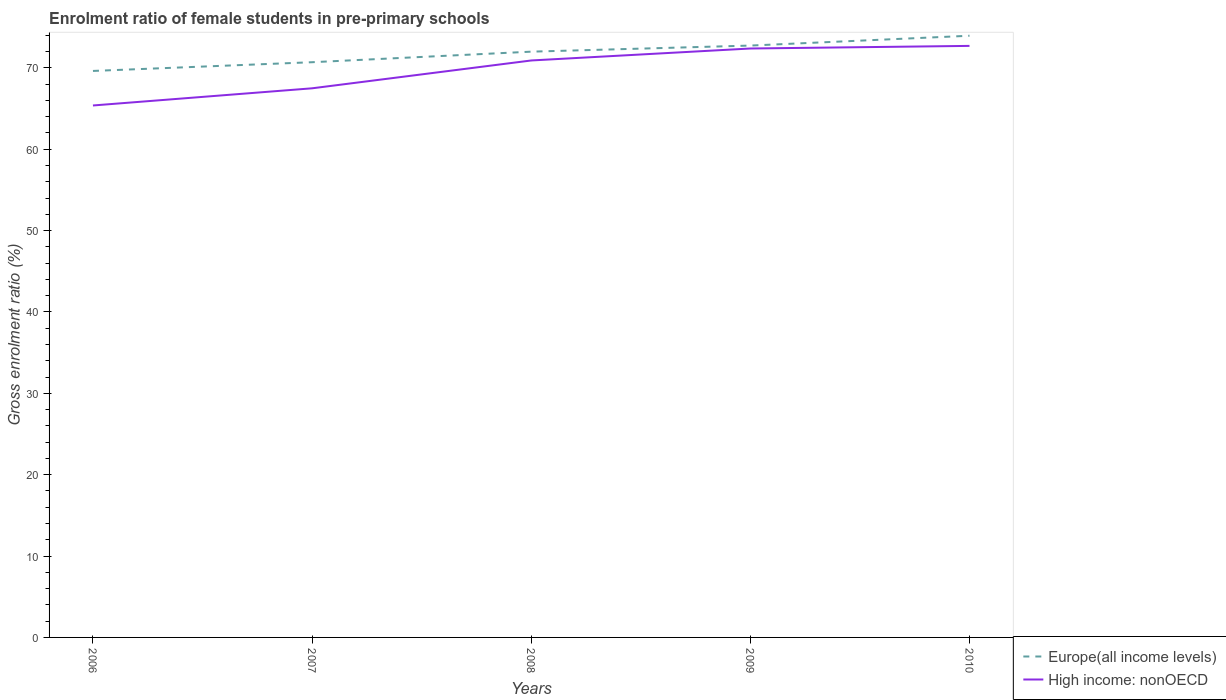Does the line corresponding to Europe(all income levels) intersect with the line corresponding to High income: nonOECD?
Your answer should be very brief. No. Is the number of lines equal to the number of legend labels?
Offer a terse response. Yes. Across all years, what is the maximum enrolment ratio of female students in pre-primary schools in High income: nonOECD?
Give a very brief answer. 65.37. In which year was the enrolment ratio of female students in pre-primary schools in High income: nonOECD maximum?
Make the answer very short. 2006. What is the total enrolment ratio of female students in pre-primary schools in Europe(all income levels) in the graph?
Offer a terse response. -2.05. What is the difference between the highest and the second highest enrolment ratio of female students in pre-primary schools in High income: nonOECD?
Offer a terse response. 7.32. How many lines are there?
Ensure brevity in your answer.  2. How many years are there in the graph?
Give a very brief answer. 5. Are the values on the major ticks of Y-axis written in scientific E-notation?
Provide a succinct answer. No. Does the graph contain any zero values?
Ensure brevity in your answer.  No. Does the graph contain grids?
Ensure brevity in your answer.  No. Where does the legend appear in the graph?
Offer a very short reply. Bottom right. What is the title of the graph?
Offer a very short reply. Enrolment ratio of female students in pre-primary schools. Does "Jordan" appear as one of the legend labels in the graph?
Your response must be concise. No. What is the Gross enrolment ratio (%) of Europe(all income levels) in 2006?
Offer a terse response. 69.62. What is the Gross enrolment ratio (%) of High income: nonOECD in 2006?
Offer a terse response. 65.37. What is the Gross enrolment ratio (%) of Europe(all income levels) in 2007?
Provide a succinct answer. 70.69. What is the Gross enrolment ratio (%) in High income: nonOECD in 2007?
Give a very brief answer. 67.48. What is the Gross enrolment ratio (%) of Europe(all income levels) in 2008?
Your answer should be compact. 71.99. What is the Gross enrolment ratio (%) in High income: nonOECD in 2008?
Offer a terse response. 70.9. What is the Gross enrolment ratio (%) in Europe(all income levels) in 2009?
Make the answer very short. 72.73. What is the Gross enrolment ratio (%) of High income: nonOECD in 2009?
Give a very brief answer. 72.37. What is the Gross enrolment ratio (%) in Europe(all income levels) in 2010?
Provide a short and direct response. 73.94. What is the Gross enrolment ratio (%) of High income: nonOECD in 2010?
Keep it short and to the point. 72.69. Across all years, what is the maximum Gross enrolment ratio (%) of Europe(all income levels)?
Offer a very short reply. 73.94. Across all years, what is the maximum Gross enrolment ratio (%) in High income: nonOECD?
Your answer should be very brief. 72.69. Across all years, what is the minimum Gross enrolment ratio (%) of Europe(all income levels)?
Keep it short and to the point. 69.62. Across all years, what is the minimum Gross enrolment ratio (%) in High income: nonOECD?
Offer a terse response. 65.37. What is the total Gross enrolment ratio (%) of Europe(all income levels) in the graph?
Give a very brief answer. 358.97. What is the total Gross enrolment ratio (%) in High income: nonOECD in the graph?
Offer a very short reply. 348.82. What is the difference between the Gross enrolment ratio (%) in Europe(all income levels) in 2006 and that in 2007?
Provide a succinct answer. -1.07. What is the difference between the Gross enrolment ratio (%) in High income: nonOECD in 2006 and that in 2007?
Offer a very short reply. -2.11. What is the difference between the Gross enrolment ratio (%) in Europe(all income levels) in 2006 and that in 2008?
Provide a succinct answer. -2.37. What is the difference between the Gross enrolment ratio (%) in High income: nonOECD in 2006 and that in 2008?
Your answer should be very brief. -5.53. What is the difference between the Gross enrolment ratio (%) in Europe(all income levels) in 2006 and that in 2009?
Your answer should be compact. -3.12. What is the difference between the Gross enrolment ratio (%) in High income: nonOECD in 2006 and that in 2009?
Make the answer very short. -7. What is the difference between the Gross enrolment ratio (%) of Europe(all income levels) in 2006 and that in 2010?
Offer a terse response. -4.33. What is the difference between the Gross enrolment ratio (%) in High income: nonOECD in 2006 and that in 2010?
Your response must be concise. -7.32. What is the difference between the Gross enrolment ratio (%) of Europe(all income levels) in 2007 and that in 2008?
Your answer should be very brief. -1.3. What is the difference between the Gross enrolment ratio (%) in High income: nonOECD in 2007 and that in 2008?
Provide a short and direct response. -3.42. What is the difference between the Gross enrolment ratio (%) in Europe(all income levels) in 2007 and that in 2009?
Offer a very short reply. -2.05. What is the difference between the Gross enrolment ratio (%) of High income: nonOECD in 2007 and that in 2009?
Provide a short and direct response. -4.89. What is the difference between the Gross enrolment ratio (%) of Europe(all income levels) in 2007 and that in 2010?
Provide a short and direct response. -3.25. What is the difference between the Gross enrolment ratio (%) in High income: nonOECD in 2007 and that in 2010?
Your answer should be very brief. -5.21. What is the difference between the Gross enrolment ratio (%) of Europe(all income levels) in 2008 and that in 2009?
Provide a short and direct response. -0.75. What is the difference between the Gross enrolment ratio (%) of High income: nonOECD in 2008 and that in 2009?
Provide a short and direct response. -1.47. What is the difference between the Gross enrolment ratio (%) of Europe(all income levels) in 2008 and that in 2010?
Offer a very short reply. -1.96. What is the difference between the Gross enrolment ratio (%) of High income: nonOECD in 2008 and that in 2010?
Make the answer very short. -1.79. What is the difference between the Gross enrolment ratio (%) of Europe(all income levels) in 2009 and that in 2010?
Provide a succinct answer. -1.21. What is the difference between the Gross enrolment ratio (%) of High income: nonOECD in 2009 and that in 2010?
Offer a very short reply. -0.32. What is the difference between the Gross enrolment ratio (%) of Europe(all income levels) in 2006 and the Gross enrolment ratio (%) of High income: nonOECD in 2007?
Provide a succinct answer. 2.13. What is the difference between the Gross enrolment ratio (%) in Europe(all income levels) in 2006 and the Gross enrolment ratio (%) in High income: nonOECD in 2008?
Give a very brief answer. -1.29. What is the difference between the Gross enrolment ratio (%) in Europe(all income levels) in 2006 and the Gross enrolment ratio (%) in High income: nonOECD in 2009?
Your response must be concise. -2.76. What is the difference between the Gross enrolment ratio (%) in Europe(all income levels) in 2006 and the Gross enrolment ratio (%) in High income: nonOECD in 2010?
Offer a very short reply. -3.08. What is the difference between the Gross enrolment ratio (%) of Europe(all income levels) in 2007 and the Gross enrolment ratio (%) of High income: nonOECD in 2008?
Make the answer very short. -0.21. What is the difference between the Gross enrolment ratio (%) in Europe(all income levels) in 2007 and the Gross enrolment ratio (%) in High income: nonOECD in 2009?
Keep it short and to the point. -1.69. What is the difference between the Gross enrolment ratio (%) in Europe(all income levels) in 2007 and the Gross enrolment ratio (%) in High income: nonOECD in 2010?
Offer a very short reply. -2.01. What is the difference between the Gross enrolment ratio (%) of Europe(all income levels) in 2008 and the Gross enrolment ratio (%) of High income: nonOECD in 2009?
Your response must be concise. -0.39. What is the difference between the Gross enrolment ratio (%) of Europe(all income levels) in 2008 and the Gross enrolment ratio (%) of High income: nonOECD in 2010?
Make the answer very short. -0.71. What is the difference between the Gross enrolment ratio (%) in Europe(all income levels) in 2009 and the Gross enrolment ratio (%) in High income: nonOECD in 2010?
Ensure brevity in your answer.  0.04. What is the average Gross enrolment ratio (%) of Europe(all income levels) per year?
Your answer should be very brief. 71.79. What is the average Gross enrolment ratio (%) in High income: nonOECD per year?
Ensure brevity in your answer.  69.76. In the year 2006, what is the difference between the Gross enrolment ratio (%) in Europe(all income levels) and Gross enrolment ratio (%) in High income: nonOECD?
Ensure brevity in your answer.  4.24. In the year 2007, what is the difference between the Gross enrolment ratio (%) in Europe(all income levels) and Gross enrolment ratio (%) in High income: nonOECD?
Provide a succinct answer. 3.21. In the year 2008, what is the difference between the Gross enrolment ratio (%) in Europe(all income levels) and Gross enrolment ratio (%) in High income: nonOECD?
Offer a terse response. 1.08. In the year 2009, what is the difference between the Gross enrolment ratio (%) of Europe(all income levels) and Gross enrolment ratio (%) of High income: nonOECD?
Your answer should be very brief. 0.36. In the year 2010, what is the difference between the Gross enrolment ratio (%) of Europe(all income levels) and Gross enrolment ratio (%) of High income: nonOECD?
Ensure brevity in your answer.  1.25. What is the ratio of the Gross enrolment ratio (%) of Europe(all income levels) in 2006 to that in 2007?
Make the answer very short. 0.98. What is the ratio of the Gross enrolment ratio (%) in High income: nonOECD in 2006 to that in 2007?
Make the answer very short. 0.97. What is the ratio of the Gross enrolment ratio (%) in Europe(all income levels) in 2006 to that in 2008?
Your answer should be compact. 0.97. What is the ratio of the Gross enrolment ratio (%) of High income: nonOECD in 2006 to that in 2008?
Your response must be concise. 0.92. What is the ratio of the Gross enrolment ratio (%) in Europe(all income levels) in 2006 to that in 2009?
Offer a very short reply. 0.96. What is the ratio of the Gross enrolment ratio (%) in High income: nonOECD in 2006 to that in 2009?
Make the answer very short. 0.9. What is the ratio of the Gross enrolment ratio (%) of Europe(all income levels) in 2006 to that in 2010?
Offer a terse response. 0.94. What is the ratio of the Gross enrolment ratio (%) of High income: nonOECD in 2006 to that in 2010?
Your response must be concise. 0.9. What is the ratio of the Gross enrolment ratio (%) of Europe(all income levels) in 2007 to that in 2008?
Provide a short and direct response. 0.98. What is the ratio of the Gross enrolment ratio (%) of High income: nonOECD in 2007 to that in 2008?
Provide a short and direct response. 0.95. What is the ratio of the Gross enrolment ratio (%) of Europe(all income levels) in 2007 to that in 2009?
Ensure brevity in your answer.  0.97. What is the ratio of the Gross enrolment ratio (%) in High income: nonOECD in 2007 to that in 2009?
Offer a terse response. 0.93. What is the ratio of the Gross enrolment ratio (%) of Europe(all income levels) in 2007 to that in 2010?
Provide a short and direct response. 0.96. What is the ratio of the Gross enrolment ratio (%) of High income: nonOECD in 2007 to that in 2010?
Give a very brief answer. 0.93. What is the ratio of the Gross enrolment ratio (%) of High income: nonOECD in 2008 to that in 2009?
Provide a succinct answer. 0.98. What is the ratio of the Gross enrolment ratio (%) in Europe(all income levels) in 2008 to that in 2010?
Make the answer very short. 0.97. What is the ratio of the Gross enrolment ratio (%) of High income: nonOECD in 2008 to that in 2010?
Keep it short and to the point. 0.98. What is the ratio of the Gross enrolment ratio (%) in Europe(all income levels) in 2009 to that in 2010?
Make the answer very short. 0.98. What is the difference between the highest and the second highest Gross enrolment ratio (%) in Europe(all income levels)?
Give a very brief answer. 1.21. What is the difference between the highest and the second highest Gross enrolment ratio (%) in High income: nonOECD?
Offer a very short reply. 0.32. What is the difference between the highest and the lowest Gross enrolment ratio (%) of Europe(all income levels)?
Offer a very short reply. 4.33. What is the difference between the highest and the lowest Gross enrolment ratio (%) of High income: nonOECD?
Your response must be concise. 7.32. 